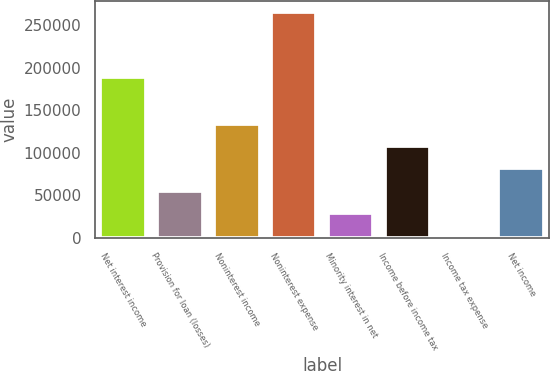<chart> <loc_0><loc_0><loc_500><loc_500><bar_chart><fcel>Net interest income<fcel>Provision for loan (losses)<fcel>Noninterest income<fcel>Noninterest expense<fcel>Minority interest in net<fcel>Income before income tax<fcel>Income tax expense<fcel>Net income<nl><fcel>188884<fcel>55591.8<fcel>134192<fcel>265191<fcel>29391.9<fcel>107992<fcel>3192<fcel>81791.7<nl></chart> 